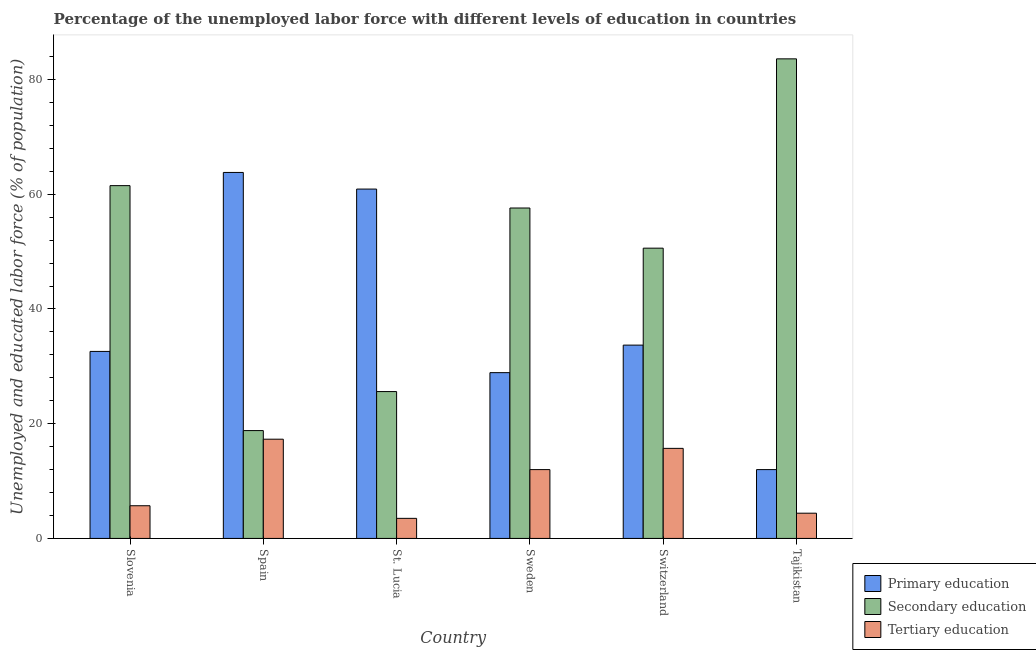Are the number of bars per tick equal to the number of legend labels?
Offer a terse response. Yes. How many bars are there on the 3rd tick from the left?
Provide a succinct answer. 3. What is the percentage of labor force who received primary education in Switzerland?
Provide a succinct answer. 33.7. Across all countries, what is the maximum percentage of labor force who received primary education?
Provide a succinct answer. 63.8. Across all countries, what is the minimum percentage of labor force who received primary education?
Your answer should be very brief. 12. In which country was the percentage of labor force who received secondary education maximum?
Offer a very short reply. Tajikistan. In which country was the percentage of labor force who received primary education minimum?
Offer a very short reply. Tajikistan. What is the total percentage of labor force who received primary education in the graph?
Offer a very short reply. 231.9. What is the difference between the percentage of labor force who received primary education in Sweden and that in Switzerland?
Keep it short and to the point. -4.8. What is the difference between the percentage of labor force who received secondary education in Tajikistan and the percentage of labor force who received tertiary education in St. Lucia?
Provide a succinct answer. 80.1. What is the average percentage of labor force who received tertiary education per country?
Make the answer very short. 9.77. What is the difference between the percentage of labor force who received primary education and percentage of labor force who received tertiary education in Slovenia?
Make the answer very short. 26.9. What is the ratio of the percentage of labor force who received secondary education in Spain to that in Sweden?
Give a very brief answer. 0.33. Is the percentage of labor force who received tertiary education in St. Lucia less than that in Tajikistan?
Give a very brief answer. Yes. Is the difference between the percentage of labor force who received tertiary education in St. Lucia and Switzerland greater than the difference between the percentage of labor force who received primary education in St. Lucia and Switzerland?
Offer a very short reply. No. What is the difference between the highest and the second highest percentage of labor force who received tertiary education?
Offer a terse response. 1.6. What is the difference between the highest and the lowest percentage of labor force who received primary education?
Your answer should be compact. 51.8. In how many countries, is the percentage of labor force who received primary education greater than the average percentage of labor force who received primary education taken over all countries?
Keep it short and to the point. 2. Is the sum of the percentage of labor force who received primary education in Sweden and Tajikistan greater than the maximum percentage of labor force who received tertiary education across all countries?
Keep it short and to the point. Yes. What does the 2nd bar from the right in Tajikistan represents?
Provide a short and direct response. Secondary education. Is it the case that in every country, the sum of the percentage of labor force who received primary education and percentage of labor force who received secondary education is greater than the percentage of labor force who received tertiary education?
Offer a very short reply. Yes. What is the difference between two consecutive major ticks on the Y-axis?
Ensure brevity in your answer.  20. Are the values on the major ticks of Y-axis written in scientific E-notation?
Your answer should be very brief. No. Does the graph contain any zero values?
Offer a terse response. No. Does the graph contain grids?
Keep it short and to the point. No. How are the legend labels stacked?
Ensure brevity in your answer.  Vertical. What is the title of the graph?
Your answer should be compact. Percentage of the unemployed labor force with different levels of education in countries. Does "Negligence towards kids" appear as one of the legend labels in the graph?
Keep it short and to the point. No. What is the label or title of the Y-axis?
Offer a very short reply. Unemployed and educated labor force (% of population). What is the Unemployed and educated labor force (% of population) in Primary education in Slovenia?
Offer a very short reply. 32.6. What is the Unemployed and educated labor force (% of population) in Secondary education in Slovenia?
Your answer should be very brief. 61.5. What is the Unemployed and educated labor force (% of population) of Tertiary education in Slovenia?
Your answer should be very brief. 5.7. What is the Unemployed and educated labor force (% of population) in Primary education in Spain?
Keep it short and to the point. 63.8. What is the Unemployed and educated labor force (% of population) in Secondary education in Spain?
Offer a very short reply. 18.8. What is the Unemployed and educated labor force (% of population) in Tertiary education in Spain?
Keep it short and to the point. 17.3. What is the Unemployed and educated labor force (% of population) of Primary education in St. Lucia?
Offer a terse response. 60.9. What is the Unemployed and educated labor force (% of population) of Secondary education in St. Lucia?
Your answer should be very brief. 25.6. What is the Unemployed and educated labor force (% of population) in Primary education in Sweden?
Make the answer very short. 28.9. What is the Unemployed and educated labor force (% of population) in Secondary education in Sweden?
Provide a short and direct response. 57.6. What is the Unemployed and educated labor force (% of population) in Primary education in Switzerland?
Offer a terse response. 33.7. What is the Unemployed and educated labor force (% of population) of Secondary education in Switzerland?
Keep it short and to the point. 50.6. What is the Unemployed and educated labor force (% of population) of Tertiary education in Switzerland?
Keep it short and to the point. 15.7. What is the Unemployed and educated labor force (% of population) in Primary education in Tajikistan?
Provide a short and direct response. 12. What is the Unemployed and educated labor force (% of population) of Secondary education in Tajikistan?
Keep it short and to the point. 83.6. What is the Unemployed and educated labor force (% of population) in Tertiary education in Tajikistan?
Provide a short and direct response. 4.4. Across all countries, what is the maximum Unemployed and educated labor force (% of population) in Primary education?
Provide a succinct answer. 63.8. Across all countries, what is the maximum Unemployed and educated labor force (% of population) in Secondary education?
Your answer should be compact. 83.6. Across all countries, what is the maximum Unemployed and educated labor force (% of population) in Tertiary education?
Your answer should be compact. 17.3. Across all countries, what is the minimum Unemployed and educated labor force (% of population) in Primary education?
Offer a very short reply. 12. Across all countries, what is the minimum Unemployed and educated labor force (% of population) of Secondary education?
Keep it short and to the point. 18.8. Across all countries, what is the minimum Unemployed and educated labor force (% of population) in Tertiary education?
Give a very brief answer. 3.5. What is the total Unemployed and educated labor force (% of population) of Primary education in the graph?
Offer a terse response. 231.9. What is the total Unemployed and educated labor force (% of population) of Secondary education in the graph?
Provide a succinct answer. 297.7. What is the total Unemployed and educated labor force (% of population) of Tertiary education in the graph?
Keep it short and to the point. 58.6. What is the difference between the Unemployed and educated labor force (% of population) of Primary education in Slovenia and that in Spain?
Your answer should be very brief. -31.2. What is the difference between the Unemployed and educated labor force (% of population) in Secondary education in Slovenia and that in Spain?
Your answer should be compact. 42.7. What is the difference between the Unemployed and educated labor force (% of population) in Tertiary education in Slovenia and that in Spain?
Offer a terse response. -11.6. What is the difference between the Unemployed and educated labor force (% of population) in Primary education in Slovenia and that in St. Lucia?
Keep it short and to the point. -28.3. What is the difference between the Unemployed and educated labor force (% of population) in Secondary education in Slovenia and that in St. Lucia?
Keep it short and to the point. 35.9. What is the difference between the Unemployed and educated labor force (% of population) in Tertiary education in Slovenia and that in St. Lucia?
Provide a short and direct response. 2.2. What is the difference between the Unemployed and educated labor force (% of population) of Primary education in Slovenia and that in Sweden?
Ensure brevity in your answer.  3.7. What is the difference between the Unemployed and educated labor force (% of population) of Primary education in Slovenia and that in Switzerland?
Offer a terse response. -1.1. What is the difference between the Unemployed and educated labor force (% of population) of Tertiary education in Slovenia and that in Switzerland?
Provide a short and direct response. -10. What is the difference between the Unemployed and educated labor force (% of population) in Primary education in Slovenia and that in Tajikistan?
Your response must be concise. 20.6. What is the difference between the Unemployed and educated labor force (% of population) in Secondary education in Slovenia and that in Tajikistan?
Offer a very short reply. -22.1. What is the difference between the Unemployed and educated labor force (% of population) in Primary education in Spain and that in St. Lucia?
Provide a succinct answer. 2.9. What is the difference between the Unemployed and educated labor force (% of population) in Primary education in Spain and that in Sweden?
Your answer should be compact. 34.9. What is the difference between the Unemployed and educated labor force (% of population) of Secondary education in Spain and that in Sweden?
Your answer should be very brief. -38.8. What is the difference between the Unemployed and educated labor force (% of population) of Primary education in Spain and that in Switzerland?
Your answer should be very brief. 30.1. What is the difference between the Unemployed and educated labor force (% of population) in Secondary education in Spain and that in Switzerland?
Give a very brief answer. -31.8. What is the difference between the Unemployed and educated labor force (% of population) in Tertiary education in Spain and that in Switzerland?
Give a very brief answer. 1.6. What is the difference between the Unemployed and educated labor force (% of population) of Primary education in Spain and that in Tajikistan?
Keep it short and to the point. 51.8. What is the difference between the Unemployed and educated labor force (% of population) of Secondary education in Spain and that in Tajikistan?
Provide a succinct answer. -64.8. What is the difference between the Unemployed and educated labor force (% of population) in Tertiary education in Spain and that in Tajikistan?
Give a very brief answer. 12.9. What is the difference between the Unemployed and educated labor force (% of population) in Primary education in St. Lucia and that in Sweden?
Provide a short and direct response. 32. What is the difference between the Unemployed and educated labor force (% of population) in Secondary education in St. Lucia and that in Sweden?
Ensure brevity in your answer.  -32. What is the difference between the Unemployed and educated labor force (% of population) in Primary education in St. Lucia and that in Switzerland?
Your response must be concise. 27.2. What is the difference between the Unemployed and educated labor force (% of population) in Secondary education in St. Lucia and that in Switzerland?
Keep it short and to the point. -25. What is the difference between the Unemployed and educated labor force (% of population) in Tertiary education in St. Lucia and that in Switzerland?
Keep it short and to the point. -12.2. What is the difference between the Unemployed and educated labor force (% of population) in Primary education in St. Lucia and that in Tajikistan?
Your answer should be compact. 48.9. What is the difference between the Unemployed and educated labor force (% of population) of Secondary education in St. Lucia and that in Tajikistan?
Provide a short and direct response. -58. What is the difference between the Unemployed and educated labor force (% of population) in Primary education in Sweden and that in Switzerland?
Make the answer very short. -4.8. What is the difference between the Unemployed and educated labor force (% of population) of Tertiary education in Sweden and that in Switzerland?
Offer a terse response. -3.7. What is the difference between the Unemployed and educated labor force (% of population) in Tertiary education in Sweden and that in Tajikistan?
Ensure brevity in your answer.  7.6. What is the difference between the Unemployed and educated labor force (% of population) of Primary education in Switzerland and that in Tajikistan?
Your answer should be compact. 21.7. What is the difference between the Unemployed and educated labor force (% of population) in Secondary education in Switzerland and that in Tajikistan?
Provide a succinct answer. -33. What is the difference between the Unemployed and educated labor force (% of population) of Primary education in Slovenia and the Unemployed and educated labor force (% of population) of Secondary education in Spain?
Your response must be concise. 13.8. What is the difference between the Unemployed and educated labor force (% of population) in Primary education in Slovenia and the Unemployed and educated labor force (% of population) in Tertiary education in Spain?
Your response must be concise. 15.3. What is the difference between the Unemployed and educated labor force (% of population) of Secondary education in Slovenia and the Unemployed and educated labor force (% of population) of Tertiary education in Spain?
Provide a succinct answer. 44.2. What is the difference between the Unemployed and educated labor force (% of population) in Primary education in Slovenia and the Unemployed and educated labor force (% of population) in Secondary education in St. Lucia?
Give a very brief answer. 7. What is the difference between the Unemployed and educated labor force (% of population) of Primary education in Slovenia and the Unemployed and educated labor force (% of population) of Tertiary education in St. Lucia?
Give a very brief answer. 29.1. What is the difference between the Unemployed and educated labor force (% of population) of Secondary education in Slovenia and the Unemployed and educated labor force (% of population) of Tertiary education in St. Lucia?
Provide a succinct answer. 58. What is the difference between the Unemployed and educated labor force (% of population) in Primary education in Slovenia and the Unemployed and educated labor force (% of population) in Tertiary education in Sweden?
Your answer should be very brief. 20.6. What is the difference between the Unemployed and educated labor force (% of population) of Secondary education in Slovenia and the Unemployed and educated labor force (% of population) of Tertiary education in Sweden?
Make the answer very short. 49.5. What is the difference between the Unemployed and educated labor force (% of population) of Primary education in Slovenia and the Unemployed and educated labor force (% of population) of Secondary education in Switzerland?
Provide a succinct answer. -18. What is the difference between the Unemployed and educated labor force (% of population) of Secondary education in Slovenia and the Unemployed and educated labor force (% of population) of Tertiary education in Switzerland?
Your answer should be compact. 45.8. What is the difference between the Unemployed and educated labor force (% of population) in Primary education in Slovenia and the Unemployed and educated labor force (% of population) in Secondary education in Tajikistan?
Offer a terse response. -51. What is the difference between the Unemployed and educated labor force (% of population) of Primary education in Slovenia and the Unemployed and educated labor force (% of population) of Tertiary education in Tajikistan?
Your answer should be compact. 28.2. What is the difference between the Unemployed and educated labor force (% of population) of Secondary education in Slovenia and the Unemployed and educated labor force (% of population) of Tertiary education in Tajikistan?
Ensure brevity in your answer.  57.1. What is the difference between the Unemployed and educated labor force (% of population) of Primary education in Spain and the Unemployed and educated labor force (% of population) of Secondary education in St. Lucia?
Keep it short and to the point. 38.2. What is the difference between the Unemployed and educated labor force (% of population) of Primary education in Spain and the Unemployed and educated labor force (% of population) of Tertiary education in St. Lucia?
Make the answer very short. 60.3. What is the difference between the Unemployed and educated labor force (% of population) in Primary education in Spain and the Unemployed and educated labor force (% of population) in Tertiary education in Sweden?
Your answer should be compact. 51.8. What is the difference between the Unemployed and educated labor force (% of population) in Secondary education in Spain and the Unemployed and educated labor force (% of population) in Tertiary education in Sweden?
Offer a terse response. 6.8. What is the difference between the Unemployed and educated labor force (% of population) of Primary education in Spain and the Unemployed and educated labor force (% of population) of Secondary education in Switzerland?
Your answer should be very brief. 13.2. What is the difference between the Unemployed and educated labor force (% of population) of Primary education in Spain and the Unemployed and educated labor force (% of population) of Tertiary education in Switzerland?
Your answer should be compact. 48.1. What is the difference between the Unemployed and educated labor force (% of population) in Secondary education in Spain and the Unemployed and educated labor force (% of population) in Tertiary education in Switzerland?
Provide a short and direct response. 3.1. What is the difference between the Unemployed and educated labor force (% of population) in Primary education in Spain and the Unemployed and educated labor force (% of population) in Secondary education in Tajikistan?
Provide a short and direct response. -19.8. What is the difference between the Unemployed and educated labor force (% of population) in Primary education in Spain and the Unemployed and educated labor force (% of population) in Tertiary education in Tajikistan?
Offer a terse response. 59.4. What is the difference between the Unemployed and educated labor force (% of population) in Secondary education in Spain and the Unemployed and educated labor force (% of population) in Tertiary education in Tajikistan?
Ensure brevity in your answer.  14.4. What is the difference between the Unemployed and educated labor force (% of population) of Primary education in St. Lucia and the Unemployed and educated labor force (% of population) of Tertiary education in Sweden?
Give a very brief answer. 48.9. What is the difference between the Unemployed and educated labor force (% of population) in Primary education in St. Lucia and the Unemployed and educated labor force (% of population) in Secondary education in Switzerland?
Provide a short and direct response. 10.3. What is the difference between the Unemployed and educated labor force (% of population) of Primary education in St. Lucia and the Unemployed and educated labor force (% of population) of Tertiary education in Switzerland?
Ensure brevity in your answer.  45.2. What is the difference between the Unemployed and educated labor force (% of population) in Primary education in St. Lucia and the Unemployed and educated labor force (% of population) in Secondary education in Tajikistan?
Make the answer very short. -22.7. What is the difference between the Unemployed and educated labor force (% of population) of Primary education in St. Lucia and the Unemployed and educated labor force (% of population) of Tertiary education in Tajikistan?
Ensure brevity in your answer.  56.5. What is the difference between the Unemployed and educated labor force (% of population) in Secondary education in St. Lucia and the Unemployed and educated labor force (% of population) in Tertiary education in Tajikistan?
Give a very brief answer. 21.2. What is the difference between the Unemployed and educated labor force (% of population) of Primary education in Sweden and the Unemployed and educated labor force (% of population) of Secondary education in Switzerland?
Keep it short and to the point. -21.7. What is the difference between the Unemployed and educated labor force (% of population) of Primary education in Sweden and the Unemployed and educated labor force (% of population) of Tertiary education in Switzerland?
Keep it short and to the point. 13.2. What is the difference between the Unemployed and educated labor force (% of population) of Secondary education in Sweden and the Unemployed and educated labor force (% of population) of Tertiary education in Switzerland?
Make the answer very short. 41.9. What is the difference between the Unemployed and educated labor force (% of population) of Primary education in Sweden and the Unemployed and educated labor force (% of population) of Secondary education in Tajikistan?
Provide a succinct answer. -54.7. What is the difference between the Unemployed and educated labor force (% of population) of Primary education in Sweden and the Unemployed and educated labor force (% of population) of Tertiary education in Tajikistan?
Your answer should be very brief. 24.5. What is the difference between the Unemployed and educated labor force (% of population) in Secondary education in Sweden and the Unemployed and educated labor force (% of population) in Tertiary education in Tajikistan?
Make the answer very short. 53.2. What is the difference between the Unemployed and educated labor force (% of population) in Primary education in Switzerland and the Unemployed and educated labor force (% of population) in Secondary education in Tajikistan?
Make the answer very short. -49.9. What is the difference between the Unemployed and educated labor force (% of population) of Primary education in Switzerland and the Unemployed and educated labor force (% of population) of Tertiary education in Tajikistan?
Provide a short and direct response. 29.3. What is the difference between the Unemployed and educated labor force (% of population) in Secondary education in Switzerland and the Unemployed and educated labor force (% of population) in Tertiary education in Tajikistan?
Ensure brevity in your answer.  46.2. What is the average Unemployed and educated labor force (% of population) of Primary education per country?
Provide a succinct answer. 38.65. What is the average Unemployed and educated labor force (% of population) of Secondary education per country?
Provide a short and direct response. 49.62. What is the average Unemployed and educated labor force (% of population) of Tertiary education per country?
Offer a very short reply. 9.77. What is the difference between the Unemployed and educated labor force (% of population) of Primary education and Unemployed and educated labor force (% of population) of Secondary education in Slovenia?
Your answer should be compact. -28.9. What is the difference between the Unemployed and educated labor force (% of population) in Primary education and Unemployed and educated labor force (% of population) in Tertiary education in Slovenia?
Your answer should be very brief. 26.9. What is the difference between the Unemployed and educated labor force (% of population) of Secondary education and Unemployed and educated labor force (% of population) of Tertiary education in Slovenia?
Your answer should be compact. 55.8. What is the difference between the Unemployed and educated labor force (% of population) of Primary education and Unemployed and educated labor force (% of population) of Tertiary education in Spain?
Ensure brevity in your answer.  46.5. What is the difference between the Unemployed and educated labor force (% of population) of Primary education and Unemployed and educated labor force (% of population) of Secondary education in St. Lucia?
Provide a succinct answer. 35.3. What is the difference between the Unemployed and educated labor force (% of population) of Primary education and Unemployed and educated labor force (% of population) of Tertiary education in St. Lucia?
Keep it short and to the point. 57.4. What is the difference between the Unemployed and educated labor force (% of population) of Secondary education and Unemployed and educated labor force (% of population) of Tertiary education in St. Lucia?
Give a very brief answer. 22.1. What is the difference between the Unemployed and educated labor force (% of population) of Primary education and Unemployed and educated labor force (% of population) of Secondary education in Sweden?
Offer a terse response. -28.7. What is the difference between the Unemployed and educated labor force (% of population) in Secondary education and Unemployed and educated labor force (% of population) in Tertiary education in Sweden?
Your answer should be compact. 45.6. What is the difference between the Unemployed and educated labor force (% of population) of Primary education and Unemployed and educated labor force (% of population) of Secondary education in Switzerland?
Provide a short and direct response. -16.9. What is the difference between the Unemployed and educated labor force (% of population) in Secondary education and Unemployed and educated labor force (% of population) in Tertiary education in Switzerland?
Provide a short and direct response. 34.9. What is the difference between the Unemployed and educated labor force (% of population) in Primary education and Unemployed and educated labor force (% of population) in Secondary education in Tajikistan?
Offer a terse response. -71.6. What is the difference between the Unemployed and educated labor force (% of population) in Primary education and Unemployed and educated labor force (% of population) in Tertiary education in Tajikistan?
Ensure brevity in your answer.  7.6. What is the difference between the Unemployed and educated labor force (% of population) of Secondary education and Unemployed and educated labor force (% of population) of Tertiary education in Tajikistan?
Offer a very short reply. 79.2. What is the ratio of the Unemployed and educated labor force (% of population) in Primary education in Slovenia to that in Spain?
Your answer should be very brief. 0.51. What is the ratio of the Unemployed and educated labor force (% of population) of Secondary education in Slovenia to that in Spain?
Offer a terse response. 3.27. What is the ratio of the Unemployed and educated labor force (% of population) in Tertiary education in Slovenia to that in Spain?
Provide a succinct answer. 0.33. What is the ratio of the Unemployed and educated labor force (% of population) in Primary education in Slovenia to that in St. Lucia?
Provide a short and direct response. 0.54. What is the ratio of the Unemployed and educated labor force (% of population) of Secondary education in Slovenia to that in St. Lucia?
Give a very brief answer. 2.4. What is the ratio of the Unemployed and educated labor force (% of population) in Tertiary education in Slovenia to that in St. Lucia?
Keep it short and to the point. 1.63. What is the ratio of the Unemployed and educated labor force (% of population) of Primary education in Slovenia to that in Sweden?
Your answer should be compact. 1.13. What is the ratio of the Unemployed and educated labor force (% of population) in Secondary education in Slovenia to that in Sweden?
Keep it short and to the point. 1.07. What is the ratio of the Unemployed and educated labor force (% of population) of Tertiary education in Slovenia to that in Sweden?
Keep it short and to the point. 0.47. What is the ratio of the Unemployed and educated labor force (% of population) of Primary education in Slovenia to that in Switzerland?
Provide a succinct answer. 0.97. What is the ratio of the Unemployed and educated labor force (% of population) in Secondary education in Slovenia to that in Switzerland?
Give a very brief answer. 1.22. What is the ratio of the Unemployed and educated labor force (% of population) of Tertiary education in Slovenia to that in Switzerland?
Ensure brevity in your answer.  0.36. What is the ratio of the Unemployed and educated labor force (% of population) in Primary education in Slovenia to that in Tajikistan?
Make the answer very short. 2.72. What is the ratio of the Unemployed and educated labor force (% of population) of Secondary education in Slovenia to that in Tajikistan?
Provide a succinct answer. 0.74. What is the ratio of the Unemployed and educated labor force (% of population) of Tertiary education in Slovenia to that in Tajikistan?
Offer a terse response. 1.3. What is the ratio of the Unemployed and educated labor force (% of population) of Primary education in Spain to that in St. Lucia?
Your answer should be compact. 1.05. What is the ratio of the Unemployed and educated labor force (% of population) in Secondary education in Spain to that in St. Lucia?
Provide a succinct answer. 0.73. What is the ratio of the Unemployed and educated labor force (% of population) of Tertiary education in Spain to that in St. Lucia?
Ensure brevity in your answer.  4.94. What is the ratio of the Unemployed and educated labor force (% of population) of Primary education in Spain to that in Sweden?
Provide a succinct answer. 2.21. What is the ratio of the Unemployed and educated labor force (% of population) in Secondary education in Spain to that in Sweden?
Give a very brief answer. 0.33. What is the ratio of the Unemployed and educated labor force (% of population) of Tertiary education in Spain to that in Sweden?
Make the answer very short. 1.44. What is the ratio of the Unemployed and educated labor force (% of population) of Primary education in Spain to that in Switzerland?
Provide a succinct answer. 1.89. What is the ratio of the Unemployed and educated labor force (% of population) in Secondary education in Spain to that in Switzerland?
Make the answer very short. 0.37. What is the ratio of the Unemployed and educated labor force (% of population) in Tertiary education in Spain to that in Switzerland?
Provide a succinct answer. 1.1. What is the ratio of the Unemployed and educated labor force (% of population) of Primary education in Spain to that in Tajikistan?
Give a very brief answer. 5.32. What is the ratio of the Unemployed and educated labor force (% of population) in Secondary education in Spain to that in Tajikistan?
Provide a succinct answer. 0.22. What is the ratio of the Unemployed and educated labor force (% of population) in Tertiary education in Spain to that in Tajikistan?
Your response must be concise. 3.93. What is the ratio of the Unemployed and educated labor force (% of population) in Primary education in St. Lucia to that in Sweden?
Make the answer very short. 2.11. What is the ratio of the Unemployed and educated labor force (% of population) in Secondary education in St. Lucia to that in Sweden?
Provide a succinct answer. 0.44. What is the ratio of the Unemployed and educated labor force (% of population) in Tertiary education in St. Lucia to that in Sweden?
Offer a terse response. 0.29. What is the ratio of the Unemployed and educated labor force (% of population) in Primary education in St. Lucia to that in Switzerland?
Offer a very short reply. 1.81. What is the ratio of the Unemployed and educated labor force (% of population) in Secondary education in St. Lucia to that in Switzerland?
Provide a short and direct response. 0.51. What is the ratio of the Unemployed and educated labor force (% of population) of Tertiary education in St. Lucia to that in Switzerland?
Your response must be concise. 0.22. What is the ratio of the Unemployed and educated labor force (% of population) in Primary education in St. Lucia to that in Tajikistan?
Provide a short and direct response. 5.08. What is the ratio of the Unemployed and educated labor force (% of population) in Secondary education in St. Lucia to that in Tajikistan?
Your answer should be compact. 0.31. What is the ratio of the Unemployed and educated labor force (% of population) of Tertiary education in St. Lucia to that in Tajikistan?
Ensure brevity in your answer.  0.8. What is the ratio of the Unemployed and educated labor force (% of population) of Primary education in Sweden to that in Switzerland?
Keep it short and to the point. 0.86. What is the ratio of the Unemployed and educated labor force (% of population) of Secondary education in Sweden to that in Switzerland?
Give a very brief answer. 1.14. What is the ratio of the Unemployed and educated labor force (% of population) in Tertiary education in Sweden to that in Switzerland?
Your answer should be very brief. 0.76. What is the ratio of the Unemployed and educated labor force (% of population) of Primary education in Sweden to that in Tajikistan?
Offer a terse response. 2.41. What is the ratio of the Unemployed and educated labor force (% of population) of Secondary education in Sweden to that in Tajikistan?
Offer a very short reply. 0.69. What is the ratio of the Unemployed and educated labor force (% of population) in Tertiary education in Sweden to that in Tajikistan?
Offer a terse response. 2.73. What is the ratio of the Unemployed and educated labor force (% of population) of Primary education in Switzerland to that in Tajikistan?
Provide a short and direct response. 2.81. What is the ratio of the Unemployed and educated labor force (% of population) of Secondary education in Switzerland to that in Tajikistan?
Provide a short and direct response. 0.61. What is the ratio of the Unemployed and educated labor force (% of population) in Tertiary education in Switzerland to that in Tajikistan?
Your response must be concise. 3.57. What is the difference between the highest and the second highest Unemployed and educated labor force (% of population) of Secondary education?
Give a very brief answer. 22.1. What is the difference between the highest and the second highest Unemployed and educated labor force (% of population) of Tertiary education?
Make the answer very short. 1.6. What is the difference between the highest and the lowest Unemployed and educated labor force (% of population) of Primary education?
Provide a short and direct response. 51.8. What is the difference between the highest and the lowest Unemployed and educated labor force (% of population) in Secondary education?
Provide a short and direct response. 64.8. 